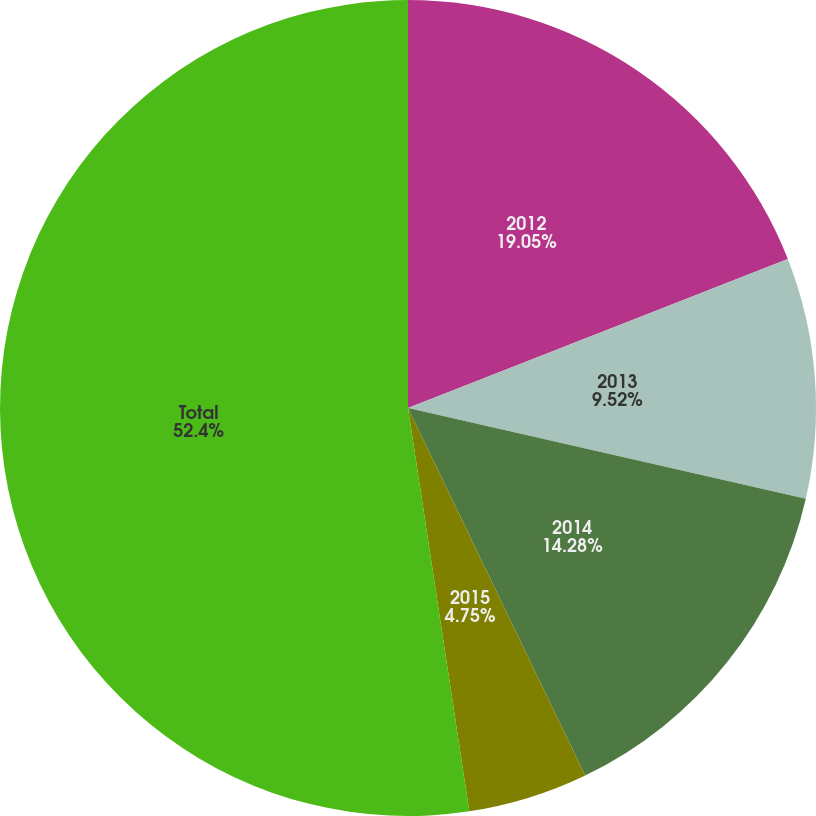Convert chart. <chart><loc_0><loc_0><loc_500><loc_500><pie_chart><fcel>2012<fcel>2013<fcel>2014<fcel>2015<fcel>Total<nl><fcel>19.05%<fcel>9.52%<fcel>14.28%<fcel>4.75%<fcel>52.4%<nl></chart> 